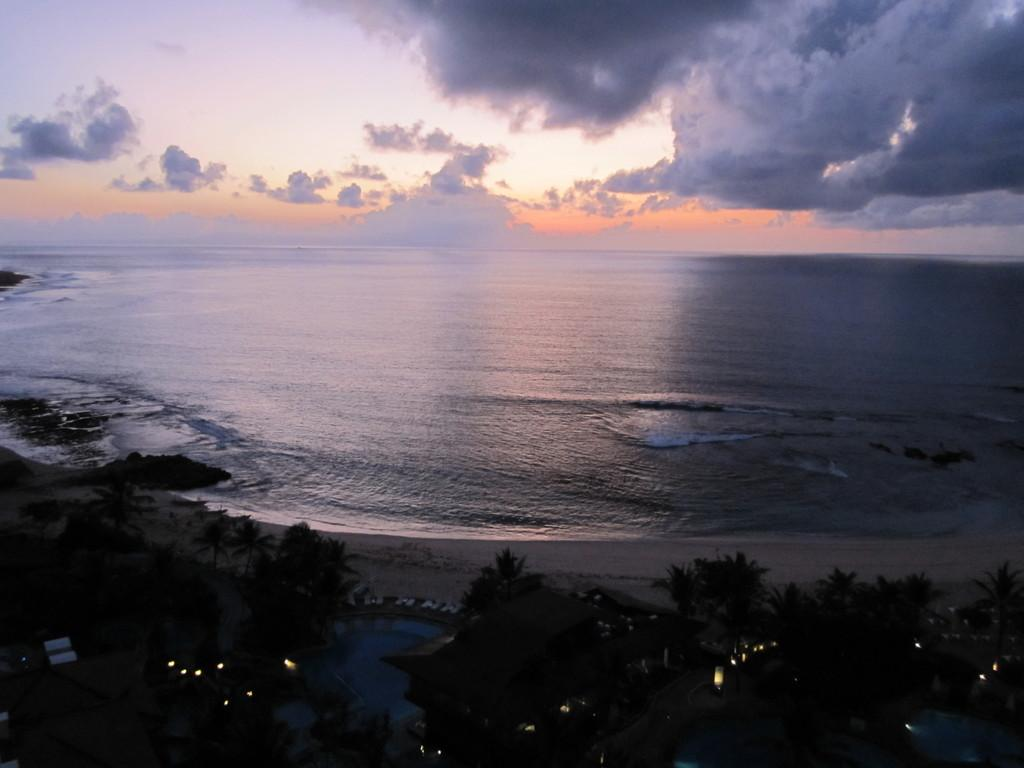What is visible in the image? Water, trees, buildings, lights, and pools are visible at the bottom of the image. The sky is visible in the background of the image, with clouds present. Can you describe the buildings in the image? The buildings at the bottom of the image are not described in detail, but they are visible alongside the trees and lights. What is the condition of the sky in the image? The sky in the image is visible in the background and has clouds present. How many frogs can be seen sitting on the wire in the image? There is no wire or frogs present in the image. Are there any sheep visible in the image? There are no sheep present in the image. 